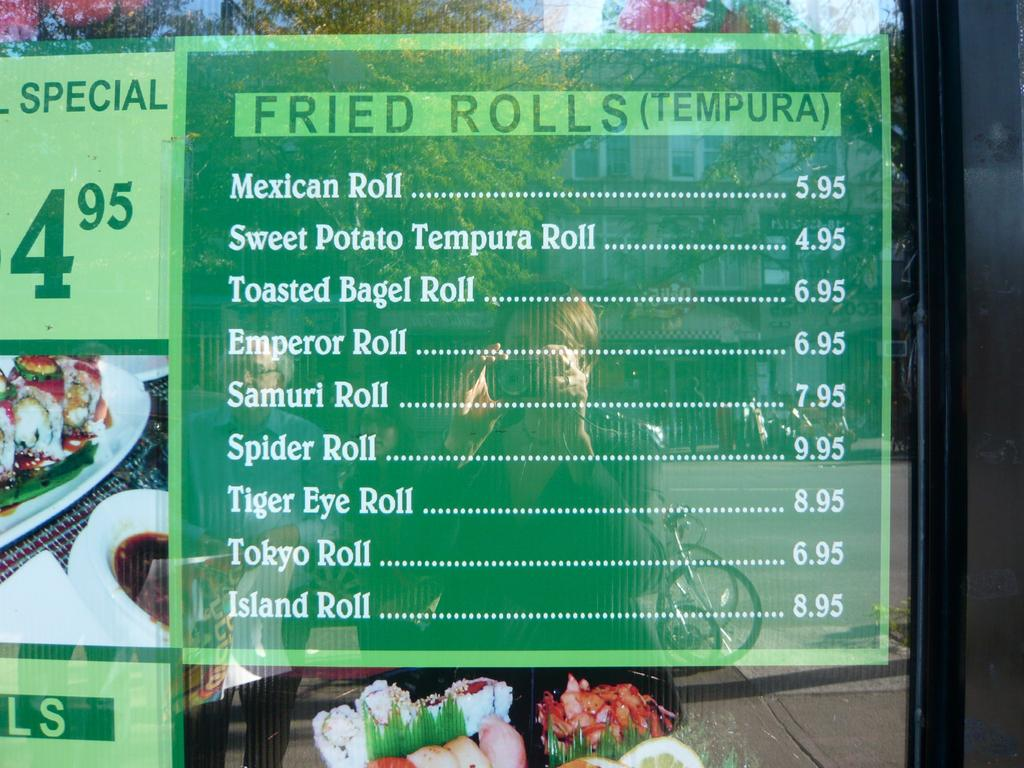What object is present in the image that can hold a liquid? There is a glass in the image. What is attached to the glass in the image? There are menu stickers attached to the glass. What can be seen reflected on the grass in the image? The images of people, a building, and trees are reflected on the grass. What type of lunch is being served in the image? There is no lunch visible in the image. What kind of teeth can be seen in the image? There are no teeth present in the image. 